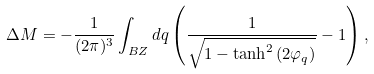Convert formula to latex. <formula><loc_0><loc_0><loc_500><loc_500>\Delta M = - \frac { 1 } { ( 2 \pi ) ^ { 3 } } \int _ { B Z } d { q } \left ( \frac { 1 } { \sqrt { 1 - \tanh ^ { 2 } { ( 2 \varphi _ { q } ) } } } - 1 \right ) ,</formula> 